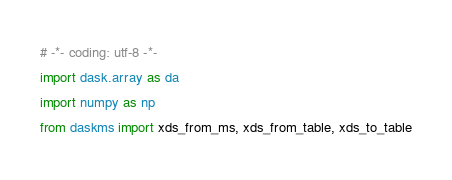Convert code to text. <code><loc_0><loc_0><loc_500><loc_500><_Python_># -*- coding: utf-8 -*-
import dask.array as da
import numpy as np
from daskms import xds_from_ms, xds_from_table, xds_to_table</code> 